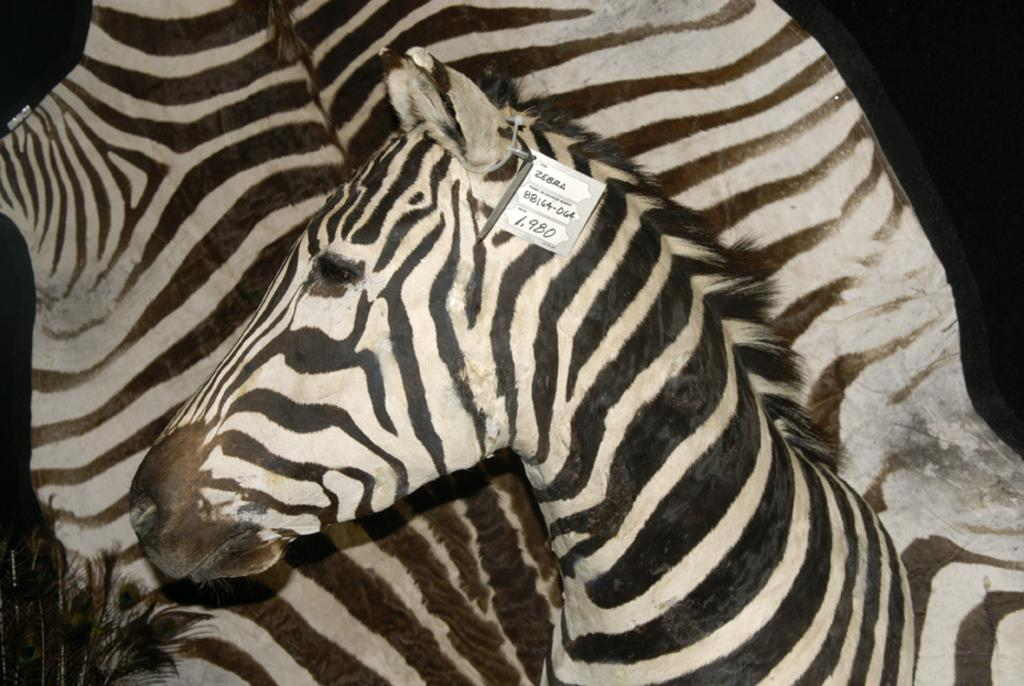What animal is the main subject of the image? There is a zebra in the image. Is there anything attached to the zebra? Yes, there is a small card tied to the zebra's ear. What type of mine can be seen in the background of the image? There is no mine present in the image; it features a zebra with a small card tied to its ear. How many snails are visible on the zebra's back in the image? There are no snails visible on the zebra's back in the image. 